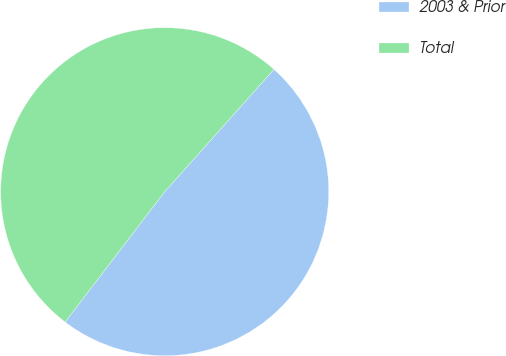<chart> <loc_0><loc_0><loc_500><loc_500><pie_chart><fcel>2003 & Prior<fcel>Total<nl><fcel>48.78%<fcel>51.22%<nl></chart> 